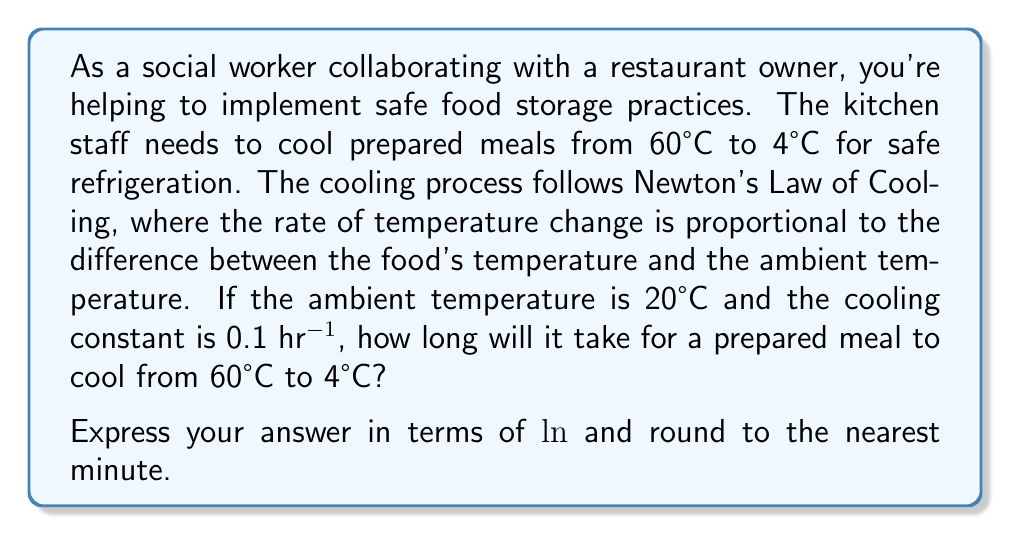Show me your answer to this math problem. Let's approach this step-by-step using Newton's Law of Cooling:

1) The differential equation for Newton's Law of Cooling is:

   $$\frac{dT}{dt} = -k(T - T_a)$$

   Where:
   - $T$ is the temperature of the food
   - $t$ is time
   - $k$ is the cooling constant
   - $T_a$ is the ambient temperature

2) We're given:
   - Initial temperature $T_0 = 60°C$
   - Final temperature $T_f = 4°C$
   - Ambient temperature $T_a = 20°C$
   - Cooling constant $k = 0.1$ hr⁻¹

3) The solution to this differential equation is:

   $$T(t) = T_a + (T_0 - T_a)e^{-kt}$$

4) We want to find $t$ when $T(t) = T_f$. Substituting:

   $$4 = 20 + (60 - 20)e^{-0.1t}$$

5) Simplifying:

   $$-16 = 40e^{-0.1t}$$

6) Dividing both sides by 40:

   $$-0.4 = e^{-0.1t}$$

7) Taking natural log of both sides:

   $$\ln(-0.4) = -0.1t$$

8) Solving for $t$:

   $$t = \frac{\ln(-0.4)}{-0.1} = 10 \ln(2.5)$$

9) Calculating the value:

   $$t \approx 9.163 \text{ hours}$$

10) Converting to minutes:

    $$9.163 \text{ hours} \times 60 \text{ minutes/hour} \approx 550 \text{ minutes}$$
Answer: $10 \ln(2.5)$ hours, or approximately 550 minutes 